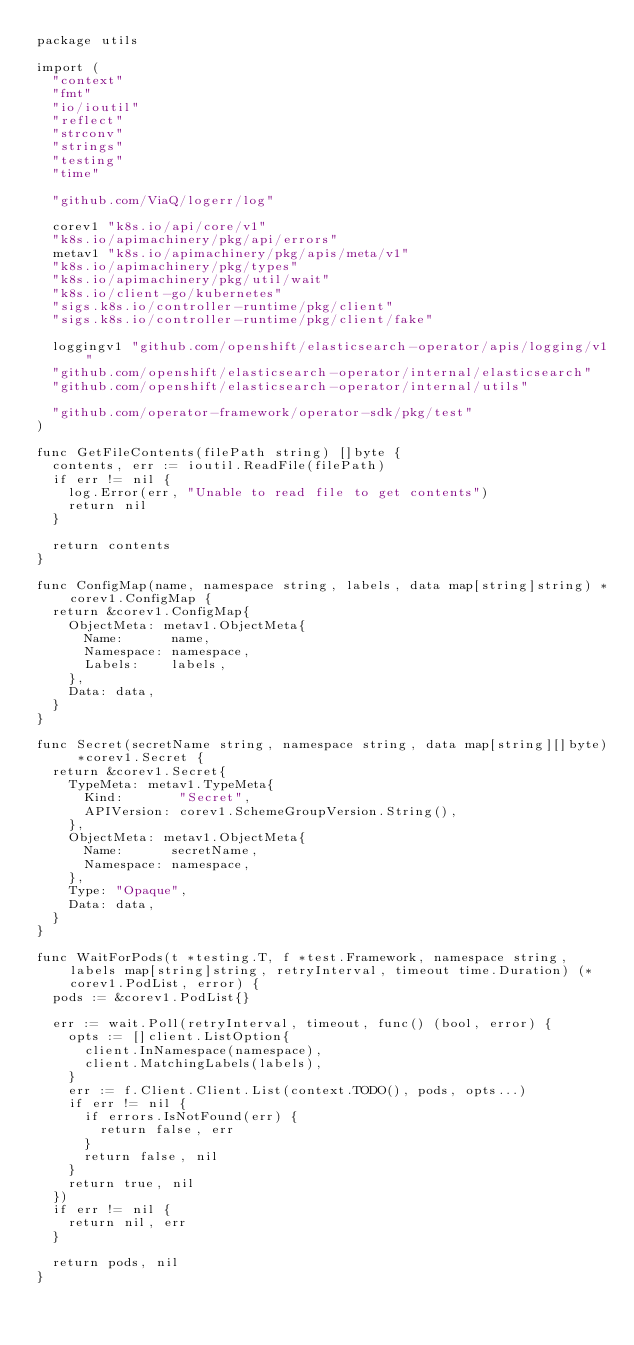Convert code to text. <code><loc_0><loc_0><loc_500><loc_500><_Go_>package utils

import (
	"context"
	"fmt"
	"io/ioutil"
	"reflect"
	"strconv"
	"strings"
	"testing"
	"time"

	"github.com/ViaQ/logerr/log"

	corev1 "k8s.io/api/core/v1"
	"k8s.io/apimachinery/pkg/api/errors"
	metav1 "k8s.io/apimachinery/pkg/apis/meta/v1"
	"k8s.io/apimachinery/pkg/types"
	"k8s.io/apimachinery/pkg/util/wait"
	"k8s.io/client-go/kubernetes"
	"sigs.k8s.io/controller-runtime/pkg/client"
	"sigs.k8s.io/controller-runtime/pkg/client/fake"

	loggingv1 "github.com/openshift/elasticsearch-operator/apis/logging/v1"
	"github.com/openshift/elasticsearch-operator/internal/elasticsearch"
	"github.com/openshift/elasticsearch-operator/internal/utils"

	"github.com/operator-framework/operator-sdk/pkg/test"
)

func GetFileContents(filePath string) []byte {
	contents, err := ioutil.ReadFile(filePath)
	if err != nil {
		log.Error(err, "Unable to read file to get contents")
		return nil
	}

	return contents
}

func ConfigMap(name, namespace string, labels, data map[string]string) *corev1.ConfigMap {
	return &corev1.ConfigMap{
		ObjectMeta: metav1.ObjectMeta{
			Name:      name,
			Namespace: namespace,
			Labels:    labels,
		},
		Data: data,
	}
}

func Secret(secretName string, namespace string, data map[string][]byte) *corev1.Secret {
	return &corev1.Secret{
		TypeMeta: metav1.TypeMeta{
			Kind:       "Secret",
			APIVersion: corev1.SchemeGroupVersion.String(),
		},
		ObjectMeta: metav1.ObjectMeta{
			Name:      secretName,
			Namespace: namespace,
		},
		Type: "Opaque",
		Data: data,
	}
}

func WaitForPods(t *testing.T, f *test.Framework, namespace string, labels map[string]string, retryInterval, timeout time.Duration) (*corev1.PodList, error) {
	pods := &corev1.PodList{}

	err := wait.Poll(retryInterval, timeout, func() (bool, error) {
		opts := []client.ListOption{
			client.InNamespace(namespace),
			client.MatchingLabels(labels),
		}
		err := f.Client.Client.List(context.TODO(), pods, opts...)
		if err != nil {
			if errors.IsNotFound(err) {
				return false, err
			}
			return false, nil
		}
		return true, nil
	})
	if err != nil {
		return nil, err
	}

	return pods, nil
}
</code> 